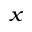<formula> <loc_0><loc_0><loc_500><loc_500>_ { x }</formula> 